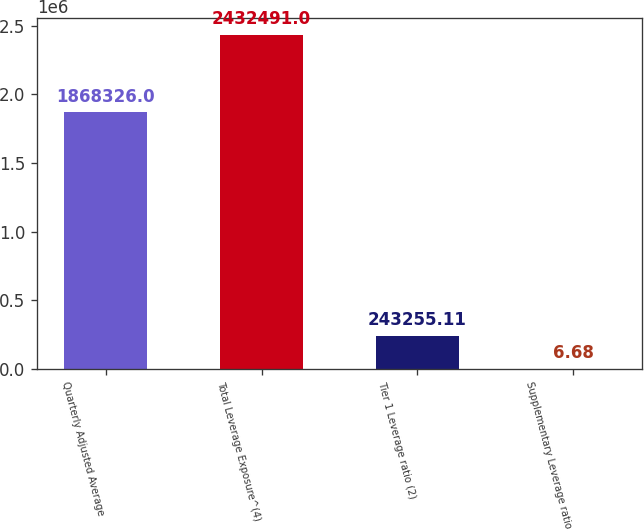<chart> <loc_0><loc_0><loc_500><loc_500><bar_chart><fcel>Quarterly Adjusted Average<fcel>Total Leverage Exposure^(4)<fcel>Tier 1 Leverage ratio (2)<fcel>Supplementary Leverage ratio<nl><fcel>1.86833e+06<fcel>2.43249e+06<fcel>243255<fcel>6.68<nl></chart> 